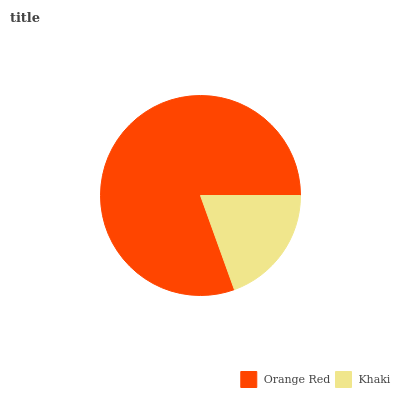Is Khaki the minimum?
Answer yes or no. Yes. Is Orange Red the maximum?
Answer yes or no. Yes. Is Khaki the maximum?
Answer yes or no. No. Is Orange Red greater than Khaki?
Answer yes or no. Yes. Is Khaki less than Orange Red?
Answer yes or no. Yes. Is Khaki greater than Orange Red?
Answer yes or no. No. Is Orange Red less than Khaki?
Answer yes or no. No. Is Orange Red the high median?
Answer yes or no. Yes. Is Khaki the low median?
Answer yes or no. Yes. Is Khaki the high median?
Answer yes or no. No. Is Orange Red the low median?
Answer yes or no. No. 